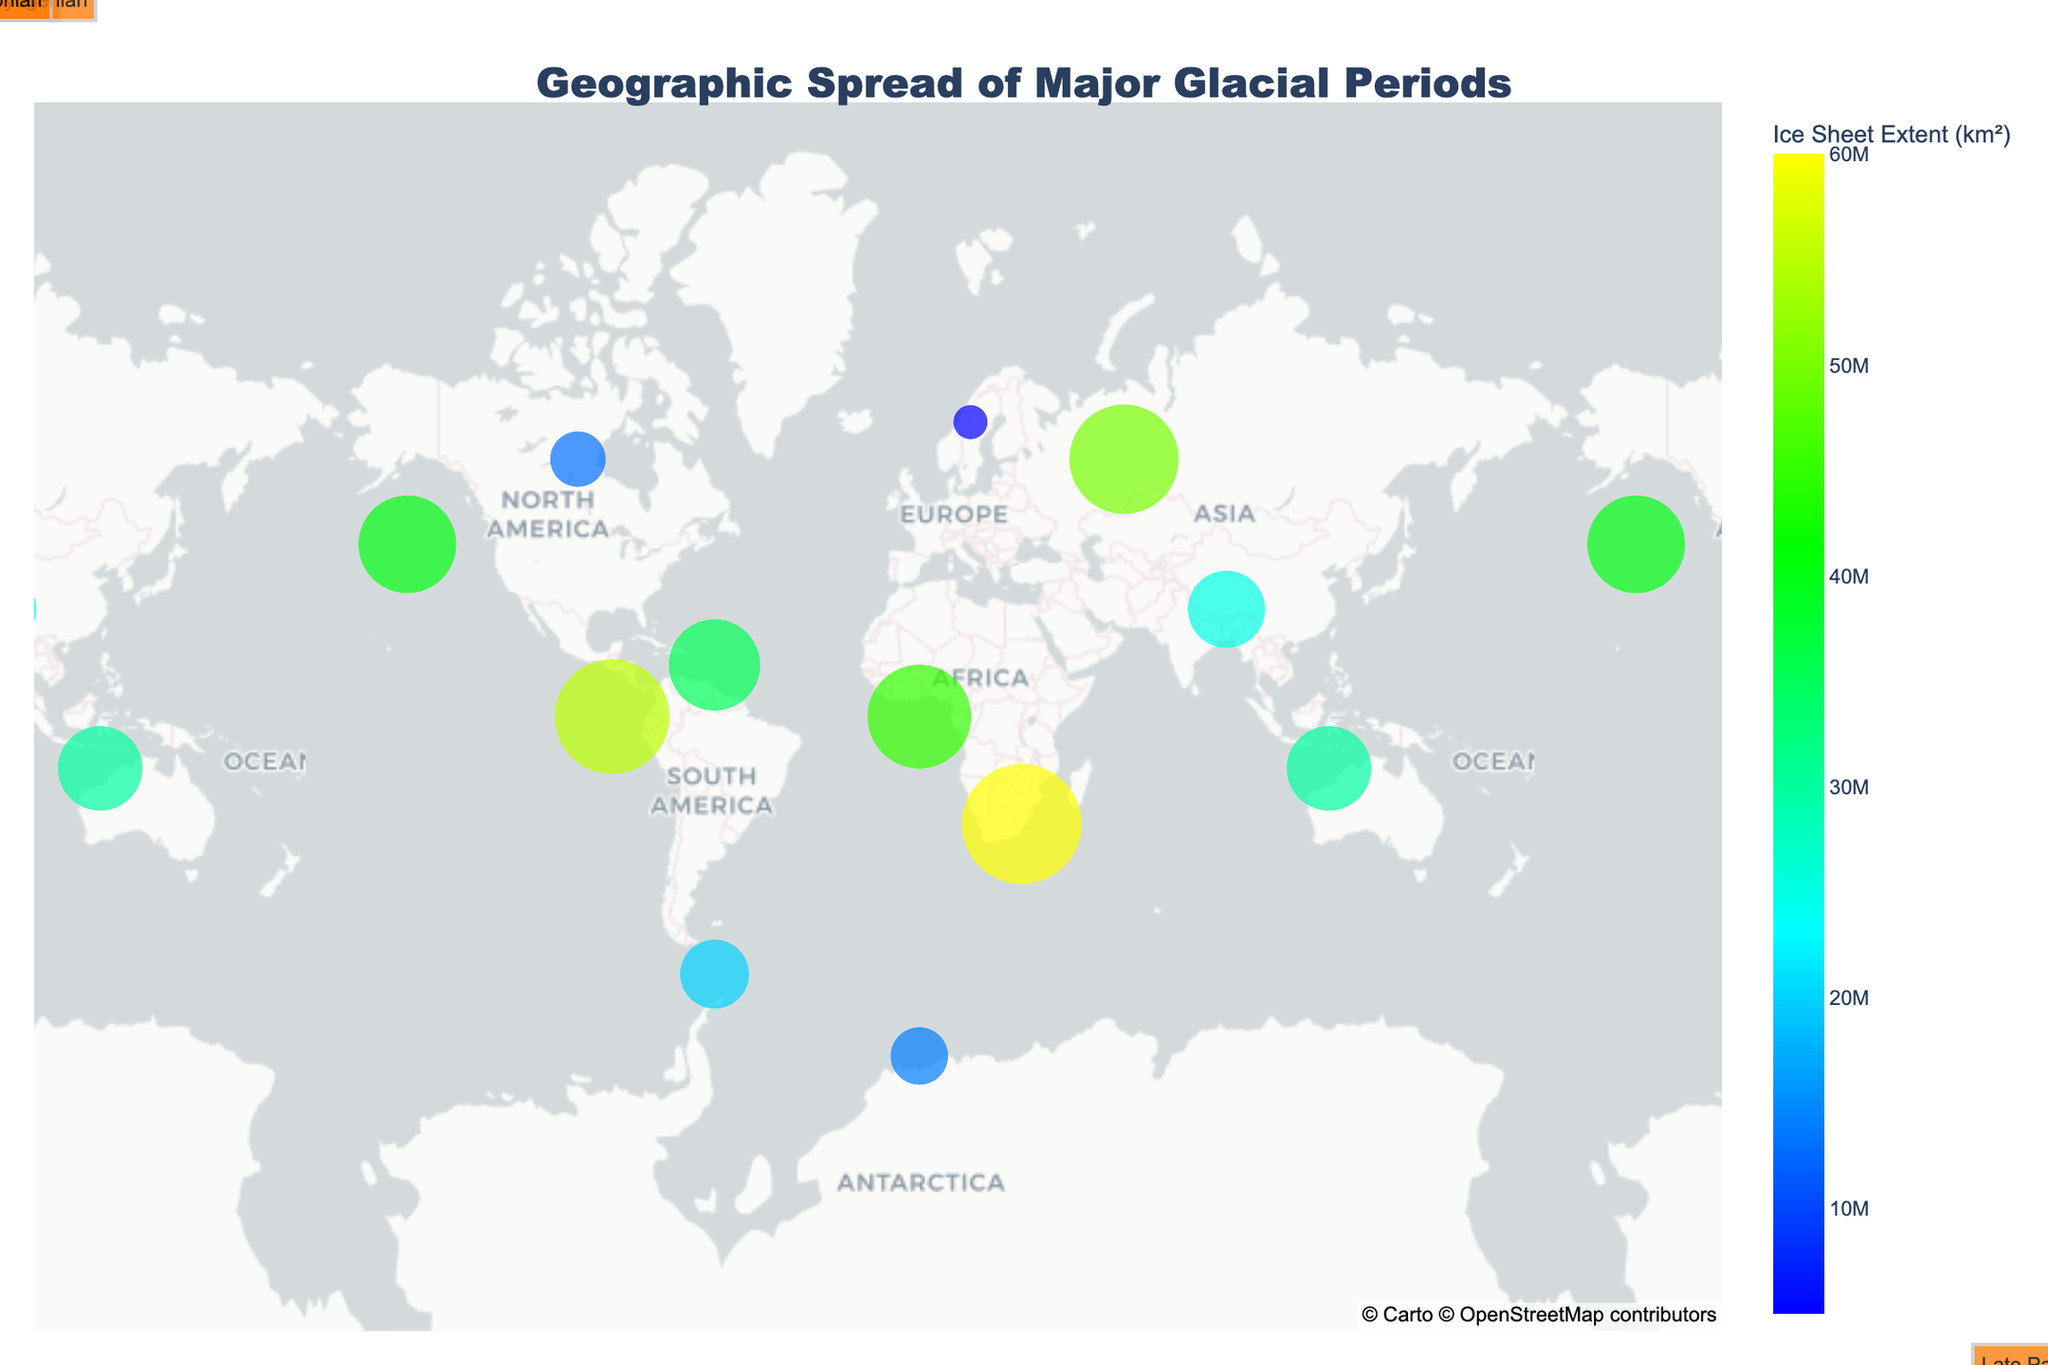How many distinct glacial periods are represented in the figure? Count the unique glacial periods annotated on the plot.
Answer: 4 What is the time period for the Quaternary glacial period? Look at the hover information for any Quaternary data point to see the time period.
Answer: 2.58 Ma to present What is the largest ice sheet extent recorded in the Cryogenian period? Hover over the data points for the Cryogenian period and check the values for Ice Sheet Extent.
Answer: 60,000,000 km² Which glacial period has the smallest ice sheet extent, and what is that extent? Compare the Ice Sheet Extent values for each glacial period and identify the smallest one.
Answer: Quaternary, 5,000,000 km² What are the average latitude and longitude coordinates for data points in the Late Paleozoic glacial period? Find the average values of the Latitude and Longitude coordinates of the Late Paleozoic data points.
Answer: 0° latitude, 15° longitude Which glacial period shows data points in both the Northern and Southern hemispheres? Look for glacial periods that have data points with both positive and negative latitude values.
Answer: Quaternary What is the difference in ice sheet extent between the largest and smallest recorded extents in the Quaternary period? Identify the largest and smallest Ice Sheet Extent values for the Quaternary period and subtract the smallest from the largest.
Answer: 8,000,000 km² Which latitude has the highest density of ice sheet extents in the Huronian glacial period? Count the number of ice sheet extent values at each latitude for the Huronian period to determine the highest density.
Answer: 45° How many data points are present in the Southern Hemisphere for the Cryogenian period? Count the data points in the Cryogenian period with negative latitude values.
Answer: 1 